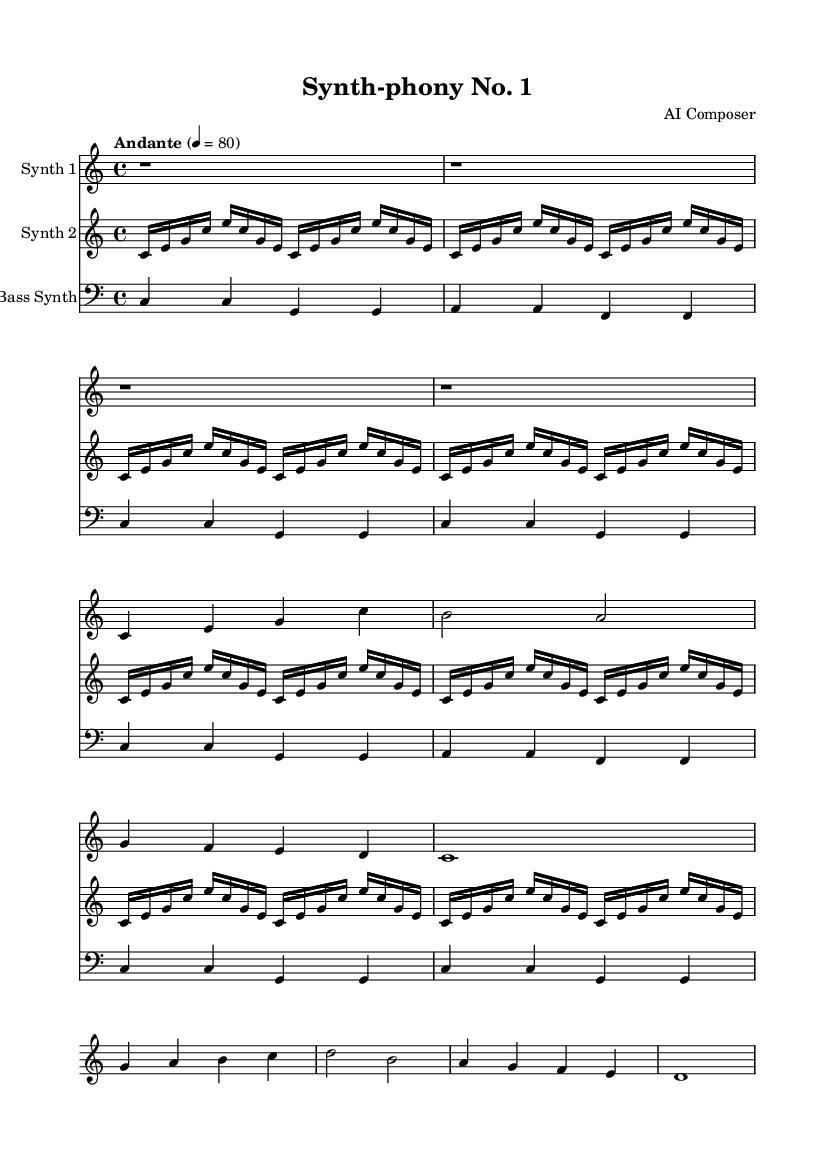What is the key signature of this music? The key signature is C major, which has no sharps or flats, as indicated at the beginning of the score.
Answer: C major What is the time signature of this music? The time signature, located next to the key signature, is 4/4, indicating four beats per measure.
Answer: 4/4 What is the tempo marking for this piece? The tempo marking is "Andante" with a metronome marking of quarter note equals 80, indicating a moderately slow tempo.
Answer: Andante, 80 How many measures are in the first staff (Synth 1)? The first staff contains a total of eight measures, which can be counted directly from the notation in the staff.
Answer: Eight Which note is the highest in Synth 1? The highest note in Synth 1 is C, which appears in measure one; it's a treble clef part, and C is positioned at the second space.
Answer: C What type of synthesizer sound is represented by the first staff? The first staff is labeled "Synth 1," suggesting it represents a melodic line generated by a synthesizer.
Answer: Synth 1 How do the rhythms in Synth 2 differ from those in the bass synth? The rhythms in Synth 2 feature rapid sixteenth notes that create a pulsing effect, while the bass synth offers quarter notes providing a steady foundation.
Answer: Rapid sixteenth notes vs. quarter notes 